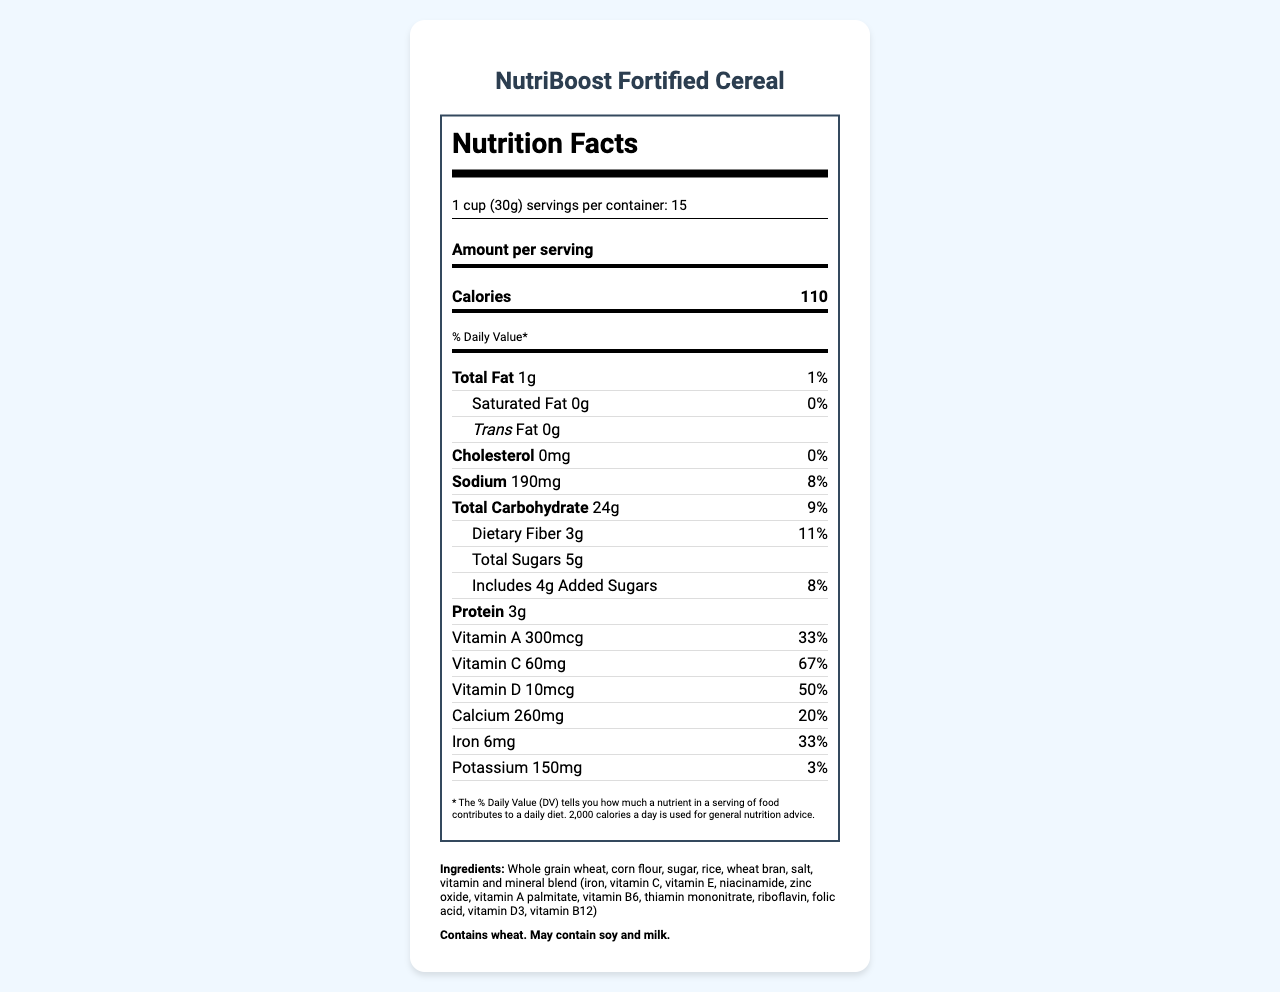what is the serving size? The serving size is explicitly mentioned under the serving information section of the document.
Answer: 1 cup (30g) how many servings are there per container? The number of servings per container is given in the serving information section.
Answer: 15 what is the amount of dietary fiber per serving? The dietary fiber amount is listed under the total carbohydrate section in the nutrition facts.
Answer: 3g how much calcium does the cereal provide per serving? The calcium content per serving is specifically mentioned in the nutrition facts under the minerals section.
Answer: 260mg which vitamin has the highest daily value percentage in the cereal? Vitamin C has a 67% daily value, which is the highest among all vitamins listed in the nutrition facts.
Answer: Vitamin C what is the primary ingredient of NutriBoost Fortified Cereal? The primary ingredient is listed first in the ingredients section.
Answer: Whole grain wheat how much protein is in one serving? The amount of protein per serving is provided under the protein section in the nutrition facts.
Answer: 3g what percentage of daily iron does one serving provide? The daily value percentage for iron is listed under the minerals section in the nutrition facts.
Answer: 33% Does the cereal contain any allergens? The allergen section specifies that the cereal contains wheat and may contain soy and milk.
Answer: Yes what is the total fat content per serving? The total fat content per serving is detailed under the total fat section in the nutrition facts.
Answer: 1g how many calories are in one serving? The number of calories per serving is prominently displayed under the calories section.
Answer: 110 which of the following vitamins have a daily value percentage over 50%? A. Vitamin A B. Vitamin C C. Vitamin D D. Vitamin B12 Vitamin C has 67% and Vitamin B12 has 63% daily value mentioned in the nutrition facts.
Answer: B. Vitamin C and D. Vitamin B12 which minerals does the cereal provide? A. Calcium, Iron, Potassium, Zinc B. Magnesium, Iron, Calcium, Phosphorus C. Calcium, Phosphorus, Sodium, Zinc D. Iron, Magnesium, Sodium, Potassium The minerals listed in the nutrition facts include calcium, iron, potassium, and zinc.
Answer: A. Calcium, Iron, Potassium, Zinc Does the cereal contain any cholesterol? The nutrition facts indicate that the cereal contains 0mg of cholesterol.
Answer: No summarize the main nutritional benefits of NutriBoost Fortified Cereal. The nutritional benefits section outlines these key points about the fortified cereal.
Answer: NutriBoost Fortified Cereal provides high levels of essential vitamins and minerals, is a good source of dietary fiber, fortified with iron to prevent anemia, contains calcium for strong bones and teeth, and provides vitamin D to support immune function. how much Vitamin E is in the cereal? The label does not provide any information on Vitamin E content.
Answer: Cannot be determined describe the purpose of the Healthy Start Food Assistance program. The distribution information section details the program name, target population, distribution centers, and partner organizations.
Answer: The program targets low-income families with children under 5 and distributes nutritious foods through various food banks and in partnership with organizations like Feeding America, Share Our Strength, and the National WIC Association. how many families does the cereal serve annually? The document mentions that the cereal serves 250000 families annually in the social impact section.
Answer: 250000 families 